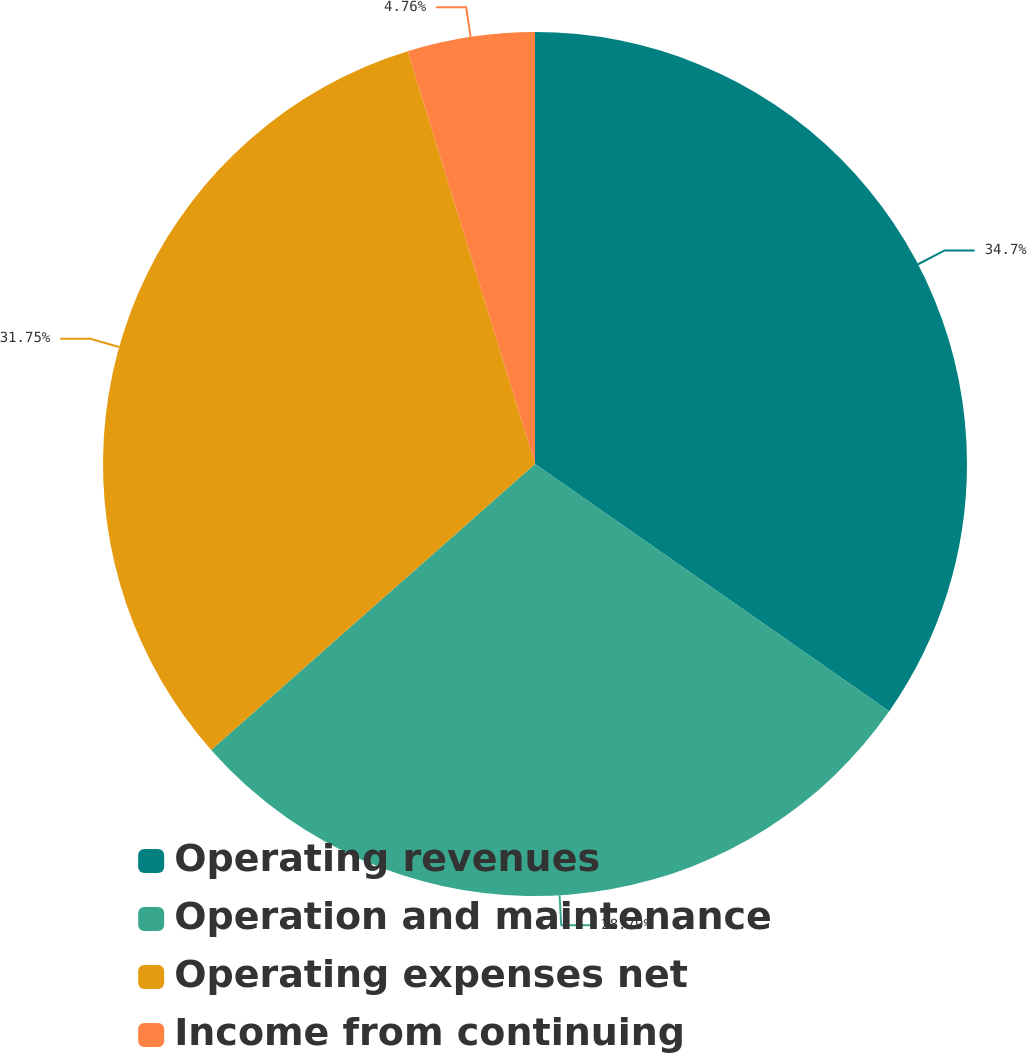Convert chart. <chart><loc_0><loc_0><loc_500><loc_500><pie_chart><fcel>Operating revenues<fcel>Operation and maintenance<fcel>Operating expenses net<fcel>Income from continuing<nl><fcel>34.7%<fcel>28.79%<fcel>31.75%<fcel>4.76%<nl></chart> 